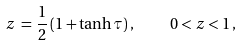Convert formula to latex. <formula><loc_0><loc_0><loc_500><loc_500>z \, = \, \frac { 1 } { 2 } \left ( 1 + \tanh \tau \right ) , \quad 0 < z < 1 \, ,</formula> 